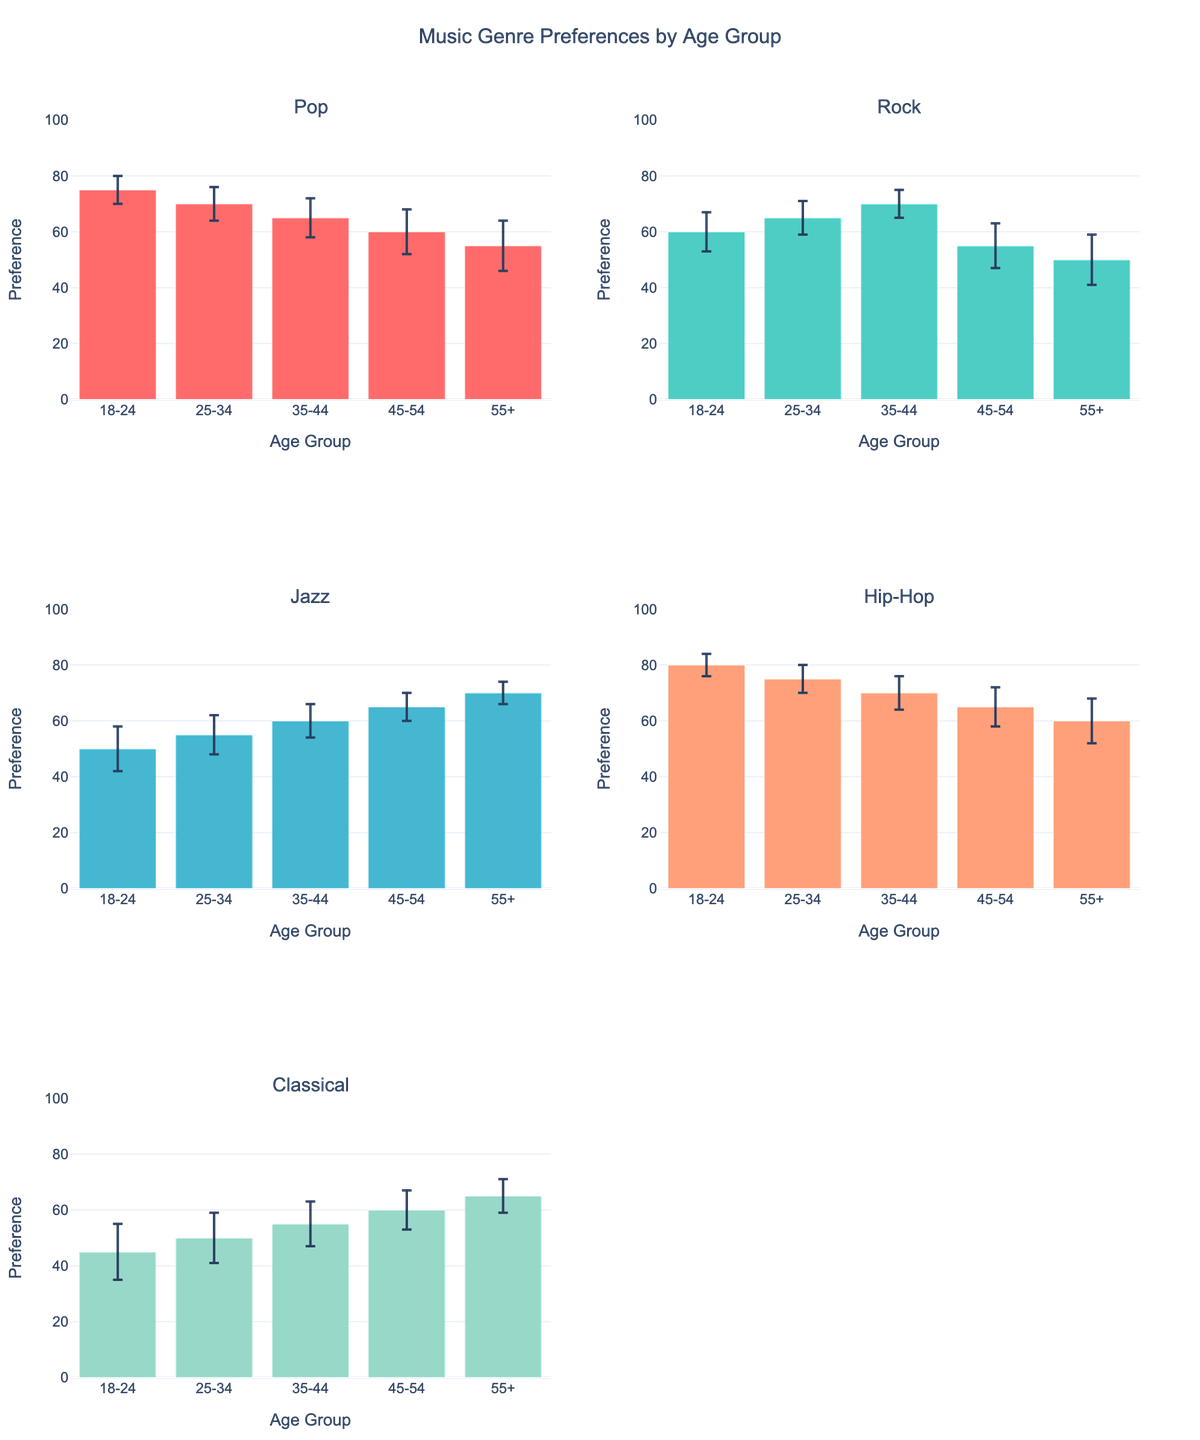What is the title of the figure? The title of the figure is displayed at the top center of the plot.
Answer: Music Genre Preferences by Age Group How many music genres are shown in the figure? The figure contains subplots for different genres, which are mentioned in the subplot titles. Count each unique genre.
Answer: 5 Which genre has the highest average preference for the 18-24 age group? Look at the bars representing the 18-24 age group in each subplot and find the highest value.
Answer: Hip-Hop Which genre shows the least preference among 55+ age group listeners? Check the bars corresponding to the 55+ age group in each subplot and find the lowest value.
Answer: Rock What is the average preference value for Jazz in the 35-44 age group and its respective standard deviation? Locate the Jazz subplot, check the bar for the 35-44 age group, and note its height and error bar.
Answer: 60 (±6) In which age group does Classical music have the highest preference? In the Classical music subplot, find the bar with the maximum height.
Answer: 55+ Compare and rank the average preference of Rock and Pop in the 25-34 age group. Identify the bars for the 25-34 age group in both Rock and Pop subplots, then compare and rank them.
Answer: Rock (65) > Pop (70) Which age group shows the most significant variability in their preference for any genre? Look for the largest error bars across all subplots, and note down the age group and genre.
Answer: Classical (18-24) What is the general trend for the Pop genre's preference as age group increases? Observe the bars in the Pop subplot to see if preference increases or decreases with age.
Answer: Decreasing How does the average preference for Hip-Hop compare to Jazz in the 45-54 age group? Check the bars for the 45-54 age group in both Hip-Hop and Jazz subplots, and compare their values.
Answer: Hip-Hop (65) > Jazz (65) 